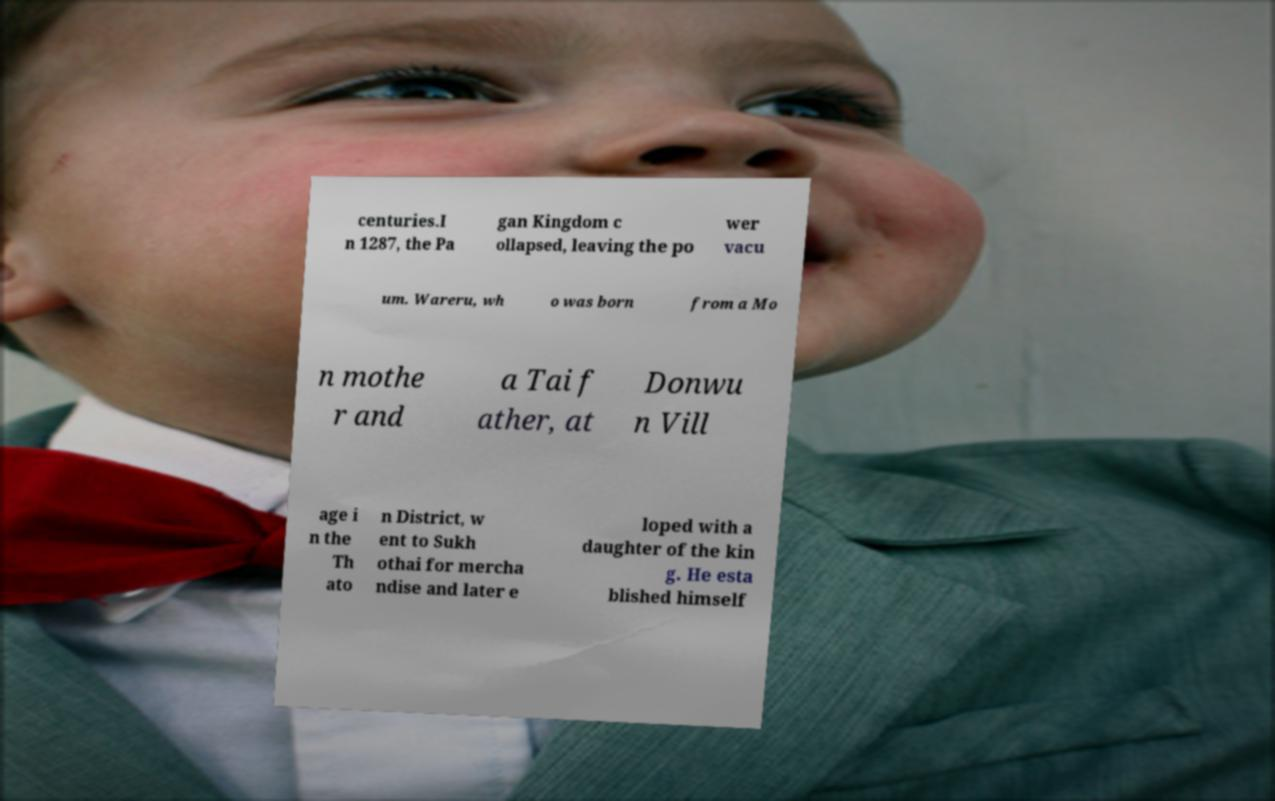Could you assist in decoding the text presented in this image and type it out clearly? centuries.I n 1287, the Pa gan Kingdom c ollapsed, leaving the po wer vacu um. Wareru, wh o was born from a Mo n mothe r and a Tai f ather, at Donwu n Vill age i n the Th ato n District, w ent to Sukh othai for mercha ndise and later e loped with a daughter of the kin g. He esta blished himself 